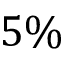<formula> <loc_0><loc_0><loc_500><loc_500>5 \%</formula> 